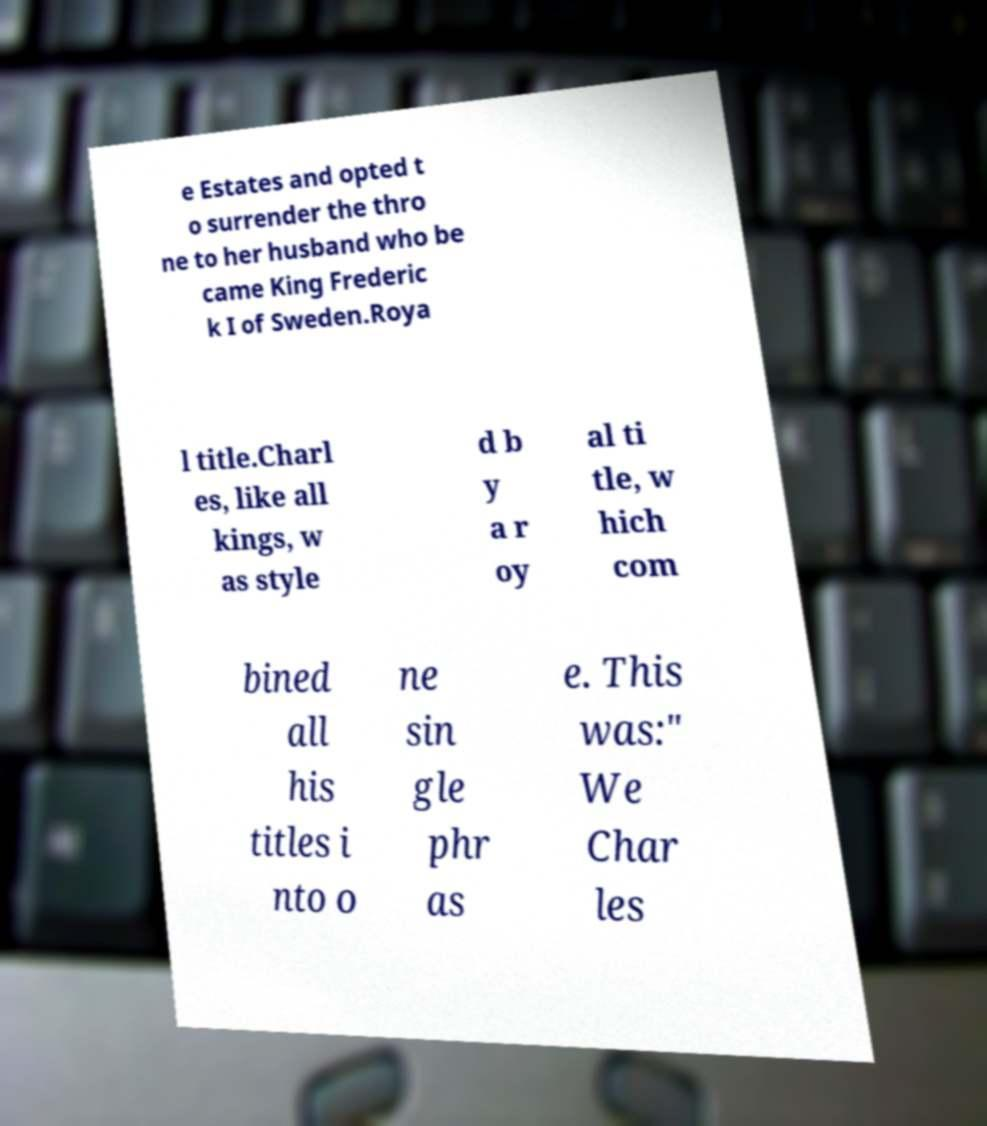Please read and relay the text visible in this image. What does it say? e Estates and opted t o surrender the thro ne to her husband who be came King Frederic k I of Sweden.Roya l title.Charl es, like all kings, w as style d b y a r oy al ti tle, w hich com bined all his titles i nto o ne sin gle phr as e. This was:" We Char les 